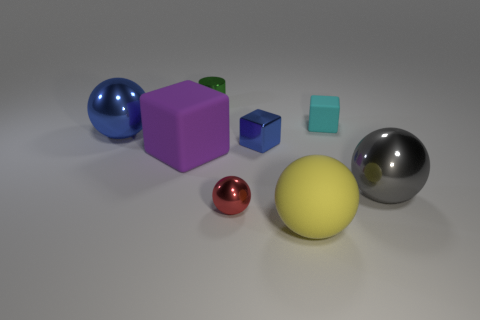Add 2 large rubber objects. How many objects exist? 10 Subtract all cylinders. How many objects are left? 7 Subtract all cyan metallic objects. Subtract all yellow matte spheres. How many objects are left? 7 Add 1 small red shiny objects. How many small red shiny objects are left? 2 Add 1 tiny green metal cylinders. How many tiny green metal cylinders exist? 2 Subtract 0 red cylinders. How many objects are left? 8 